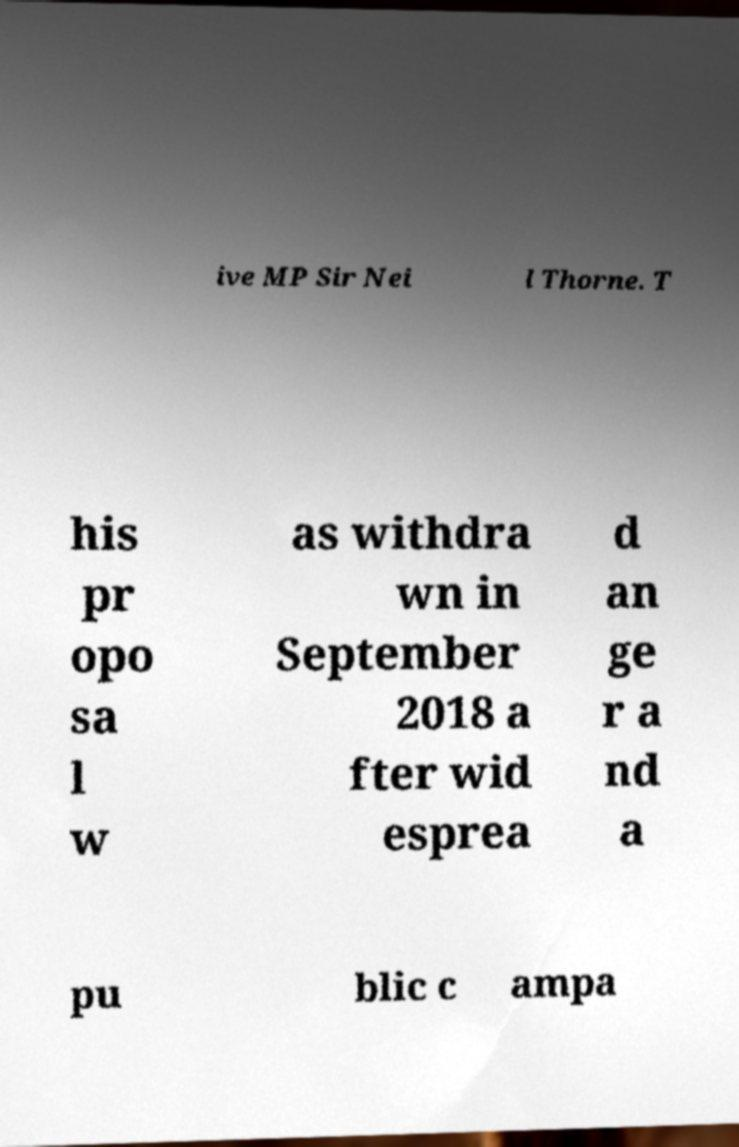Can you accurately transcribe the text from the provided image for me? ive MP Sir Nei l Thorne. T his pr opo sa l w as withdra wn in September 2018 a fter wid esprea d an ge r a nd a pu blic c ampa 